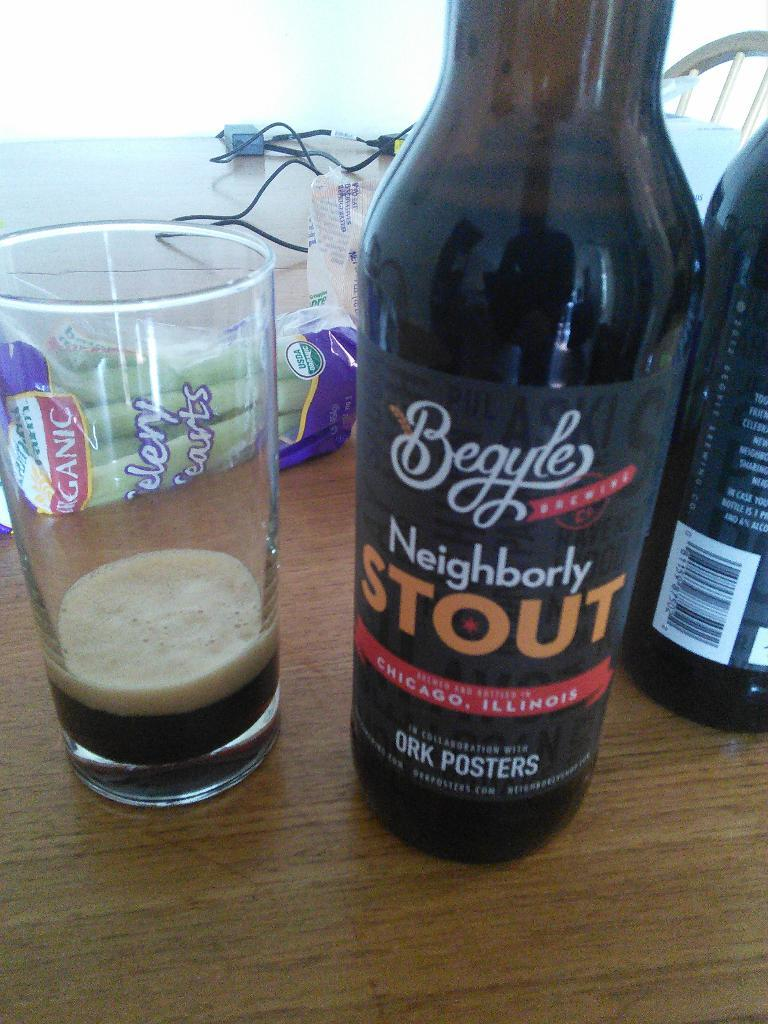<image>
Share a concise interpretation of the image provided. A bottle of Neighborly Stout drink sits beside a clear glass with a bit of the drink poured inside. 